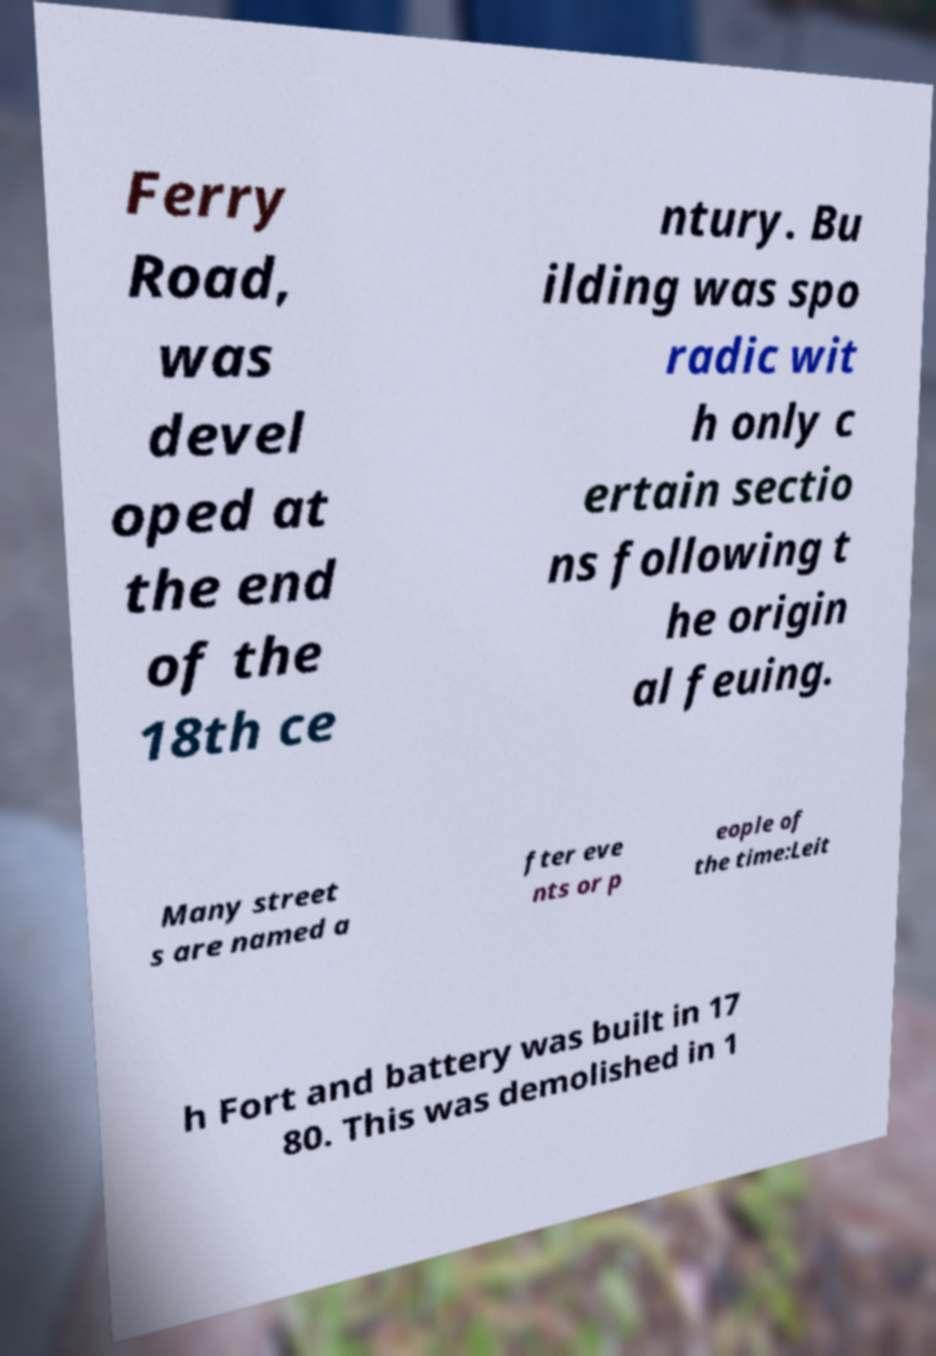For documentation purposes, I need the text within this image transcribed. Could you provide that? Ferry Road, was devel oped at the end of the 18th ce ntury. Bu ilding was spo radic wit h only c ertain sectio ns following t he origin al feuing. Many street s are named a fter eve nts or p eople of the time:Leit h Fort and battery was built in 17 80. This was demolished in 1 